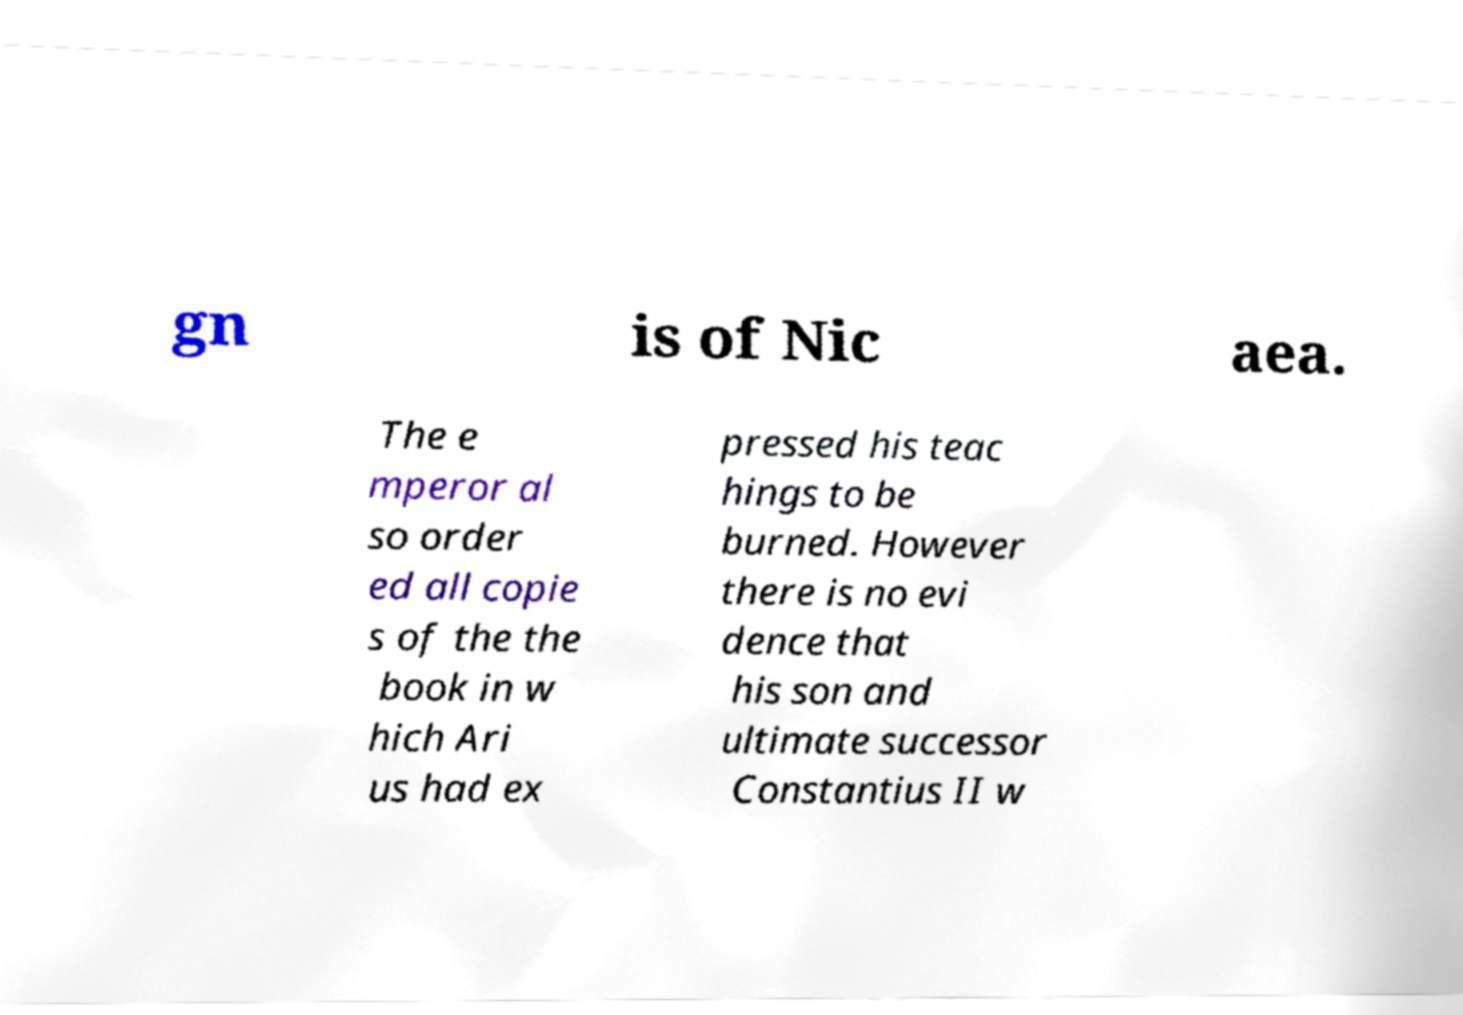Please identify and transcribe the text found in this image. gn is of Nic aea. The e mperor al so order ed all copie s of the the book in w hich Ari us had ex pressed his teac hings to be burned. However there is no evi dence that his son and ultimate successor Constantius II w 